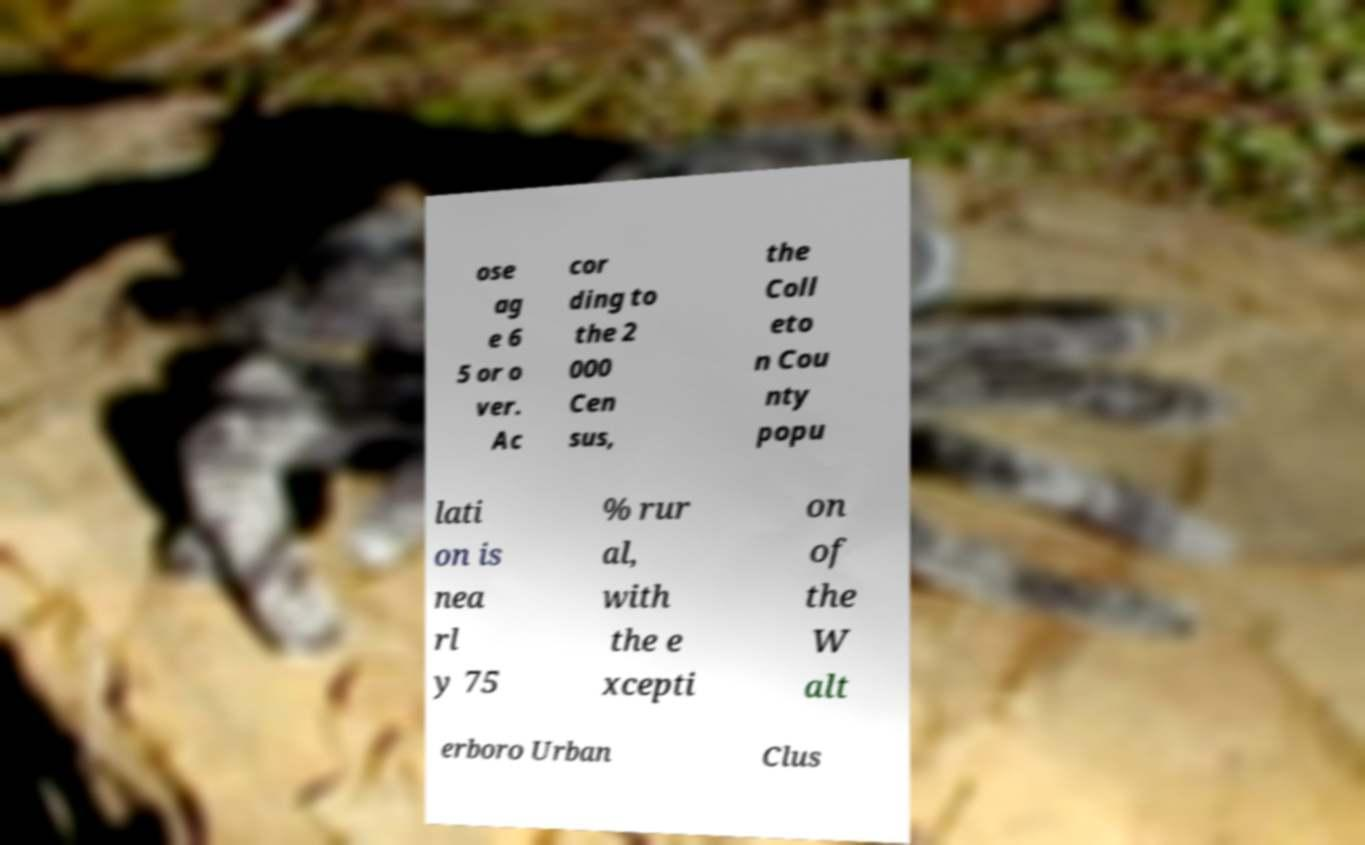Could you assist in decoding the text presented in this image and type it out clearly? ose ag e 6 5 or o ver. Ac cor ding to the 2 000 Cen sus, the Coll eto n Cou nty popu lati on is nea rl y 75 % rur al, with the e xcepti on of the W alt erboro Urban Clus 